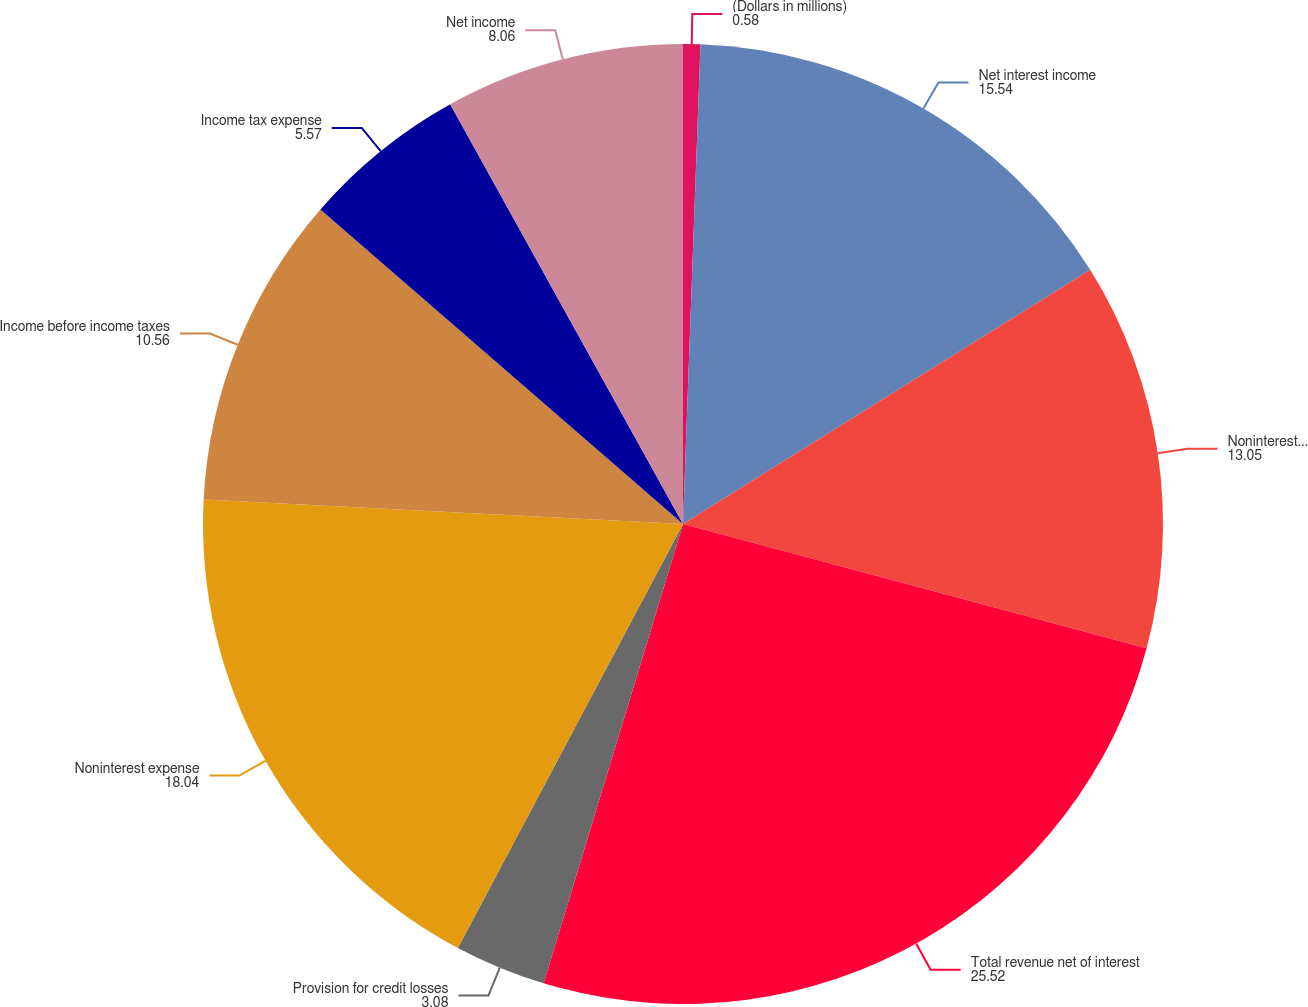Convert chart to OTSL. <chart><loc_0><loc_0><loc_500><loc_500><pie_chart><fcel>(Dollars in millions)<fcel>Net interest income<fcel>Noninterest income<fcel>Total revenue net of interest<fcel>Provision for credit losses<fcel>Noninterest expense<fcel>Income before income taxes<fcel>Income tax expense<fcel>Net income<nl><fcel>0.58%<fcel>15.54%<fcel>13.05%<fcel>25.52%<fcel>3.08%<fcel>18.04%<fcel>10.56%<fcel>5.57%<fcel>8.06%<nl></chart> 